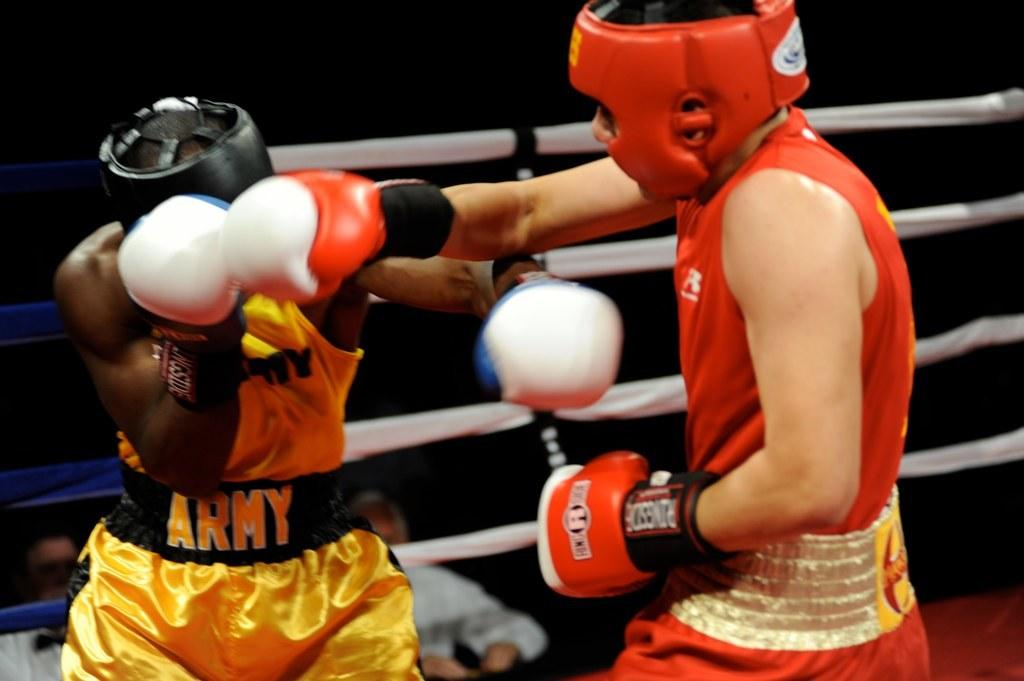How many people are present in the image? There are two persons in different color dresses in the image. What are the two persons doing in the image? The two persons are fighting on a stage. What is located beside the stage? There is a fence beside the stage. Can you describe the background of the image? There are two persons in the background of the image, and the background is dark in color. What type of leaf is being used as a cart by the persons in the image? There is no leaf or cart present in the image; the two persons are fighting on a stage. 